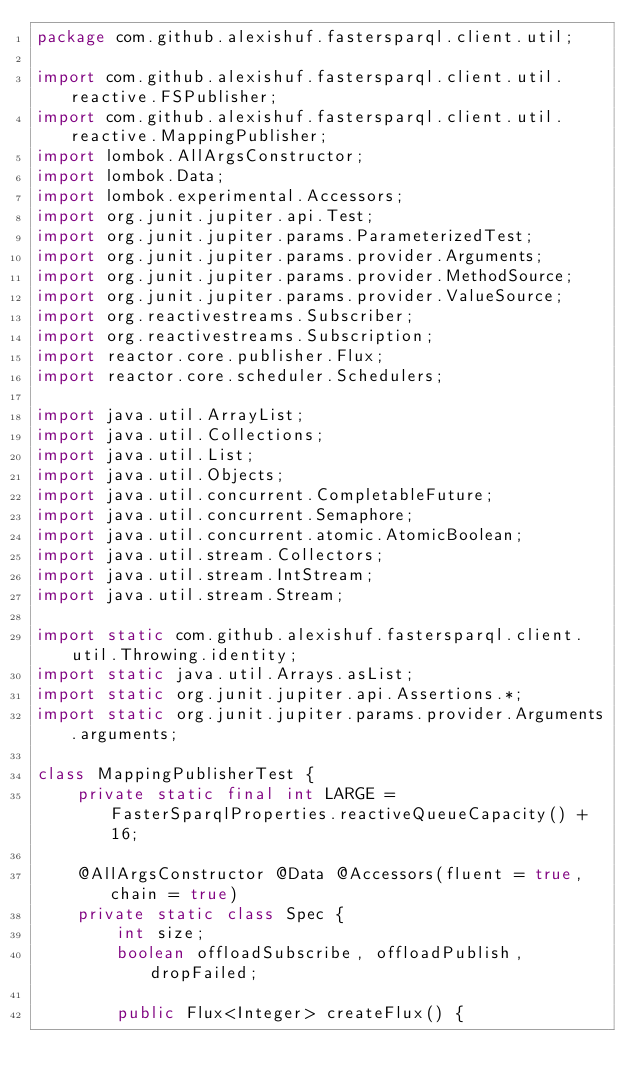<code> <loc_0><loc_0><loc_500><loc_500><_Java_>package com.github.alexishuf.fastersparql.client.util;

import com.github.alexishuf.fastersparql.client.util.reactive.FSPublisher;
import com.github.alexishuf.fastersparql.client.util.reactive.MappingPublisher;
import lombok.AllArgsConstructor;
import lombok.Data;
import lombok.experimental.Accessors;
import org.junit.jupiter.api.Test;
import org.junit.jupiter.params.ParameterizedTest;
import org.junit.jupiter.params.provider.Arguments;
import org.junit.jupiter.params.provider.MethodSource;
import org.junit.jupiter.params.provider.ValueSource;
import org.reactivestreams.Subscriber;
import org.reactivestreams.Subscription;
import reactor.core.publisher.Flux;
import reactor.core.scheduler.Schedulers;

import java.util.ArrayList;
import java.util.Collections;
import java.util.List;
import java.util.Objects;
import java.util.concurrent.CompletableFuture;
import java.util.concurrent.Semaphore;
import java.util.concurrent.atomic.AtomicBoolean;
import java.util.stream.Collectors;
import java.util.stream.IntStream;
import java.util.stream.Stream;

import static com.github.alexishuf.fastersparql.client.util.Throwing.identity;
import static java.util.Arrays.asList;
import static org.junit.jupiter.api.Assertions.*;
import static org.junit.jupiter.params.provider.Arguments.arguments;

class MappingPublisherTest {
    private static final int LARGE = FasterSparqlProperties.reactiveQueueCapacity() + 16;

    @AllArgsConstructor @Data @Accessors(fluent = true, chain = true)
    private static class Spec {
        int size;
        boolean offloadSubscribe, offloadPublish, dropFailed;

        public Flux<Integer> createFlux() {</code> 